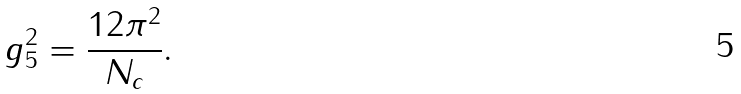Convert formula to latex. <formula><loc_0><loc_0><loc_500><loc_500>g _ { 5 } ^ { 2 } = \frac { 1 2 \pi ^ { 2 } } { N _ { c } } .</formula> 